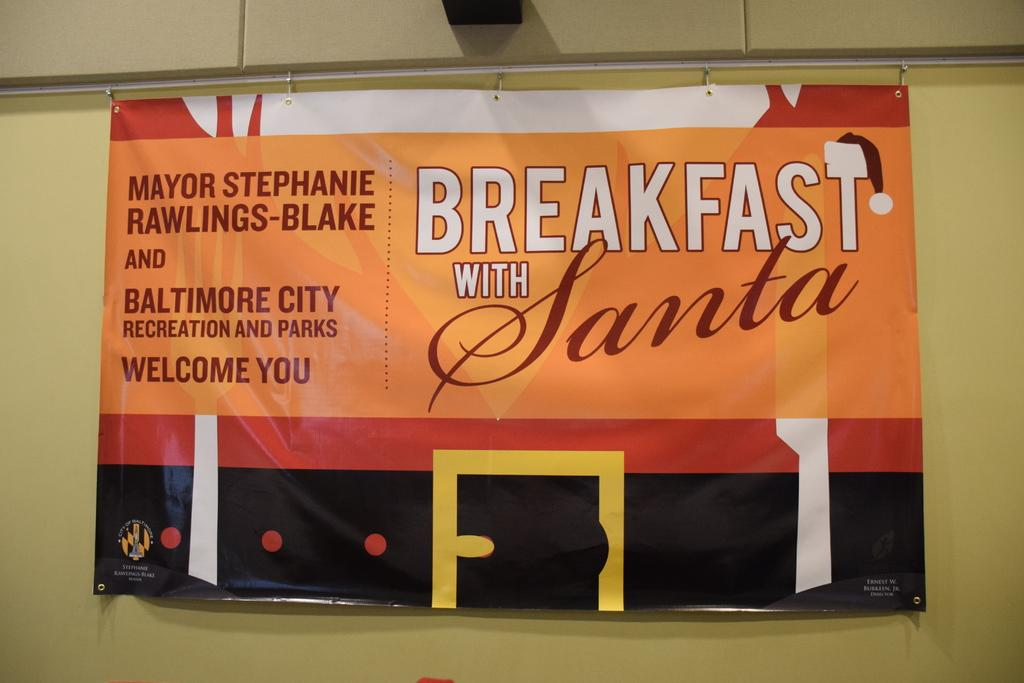What type of structure can be seen in the image? There is a wall in the image. What decorative item is present in the image? There is a pompom in the image. What can be read or seen in written form in the image? There is text visible in the image. Where is the partner sitting at the desk in the image? There is no partner or desk present in the image. 